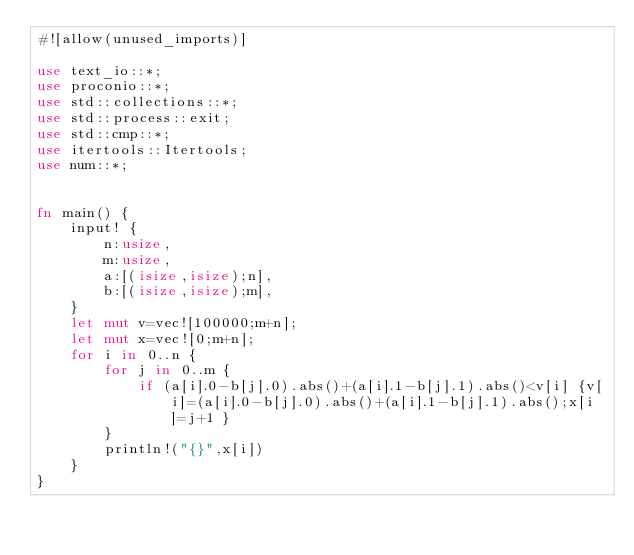<code> <loc_0><loc_0><loc_500><loc_500><_Rust_>#![allow(unused_imports)]

use text_io::*;
use proconio::*;
use std::collections::*;
use std::process::exit;
use std::cmp::*;
use itertools::Itertools;
use num::*;


fn main() {
    input! {
        n:usize,
        m:usize,
        a:[(isize,isize);n],
        b:[(isize,isize);m],
    }
    let mut v=vec![100000;m+n];
    let mut x=vec![0;m+n];
    for i in 0..n {
        for j in 0..m {
            if (a[i].0-b[j].0).abs()+(a[i].1-b[j].1).abs()<v[i] {v[i]=(a[i].0-b[j].0).abs()+(a[i].1-b[j].1).abs();x[i]=j+1 }
        }
        println!("{}",x[i])
    }
}</code> 